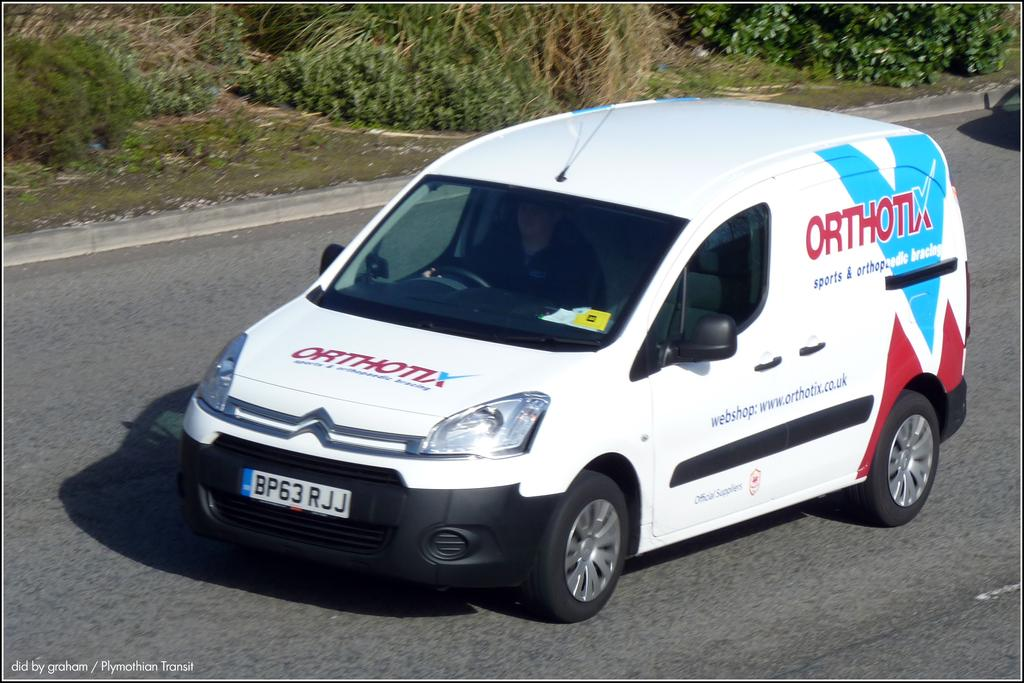<image>
Create a compact narrative representing the image presented. White van with the word ORTHOTIX in red on it. 